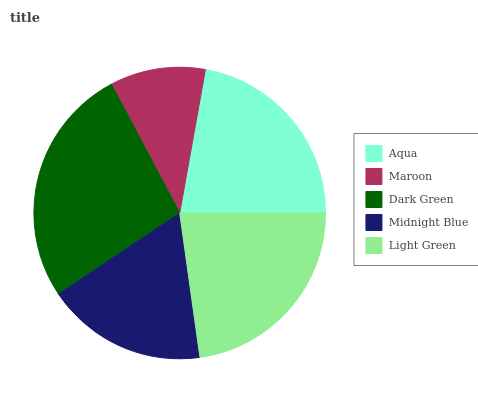Is Maroon the minimum?
Answer yes or no. Yes. Is Dark Green the maximum?
Answer yes or no. Yes. Is Dark Green the minimum?
Answer yes or no. No. Is Maroon the maximum?
Answer yes or no. No. Is Dark Green greater than Maroon?
Answer yes or no. Yes. Is Maroon less than Dark Green?
Answer yes or no. Yes. Is Maroon greater than Dark Green?
Answer yes or no. No. Is Dark Green less than Maroon?
Answer yes or no. No. Is Aqua the high median?
Answer yes or no. Yes. Is Aqua the low median?
Answer yes or no. Yes. Is Dark Green the high median?
Answer yes or no. No. Is Midnight Blue the low median?
Answer yes or no. No. 